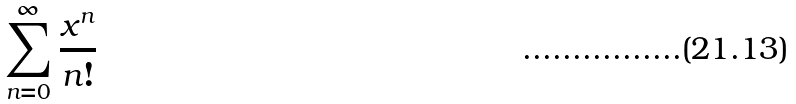<formula> <loc_0><loc_0><loc_500><loc_500>\sum _ { n = 0 } ^ { \infty } \frac { x ^ { n } } { n ! }</formula> 